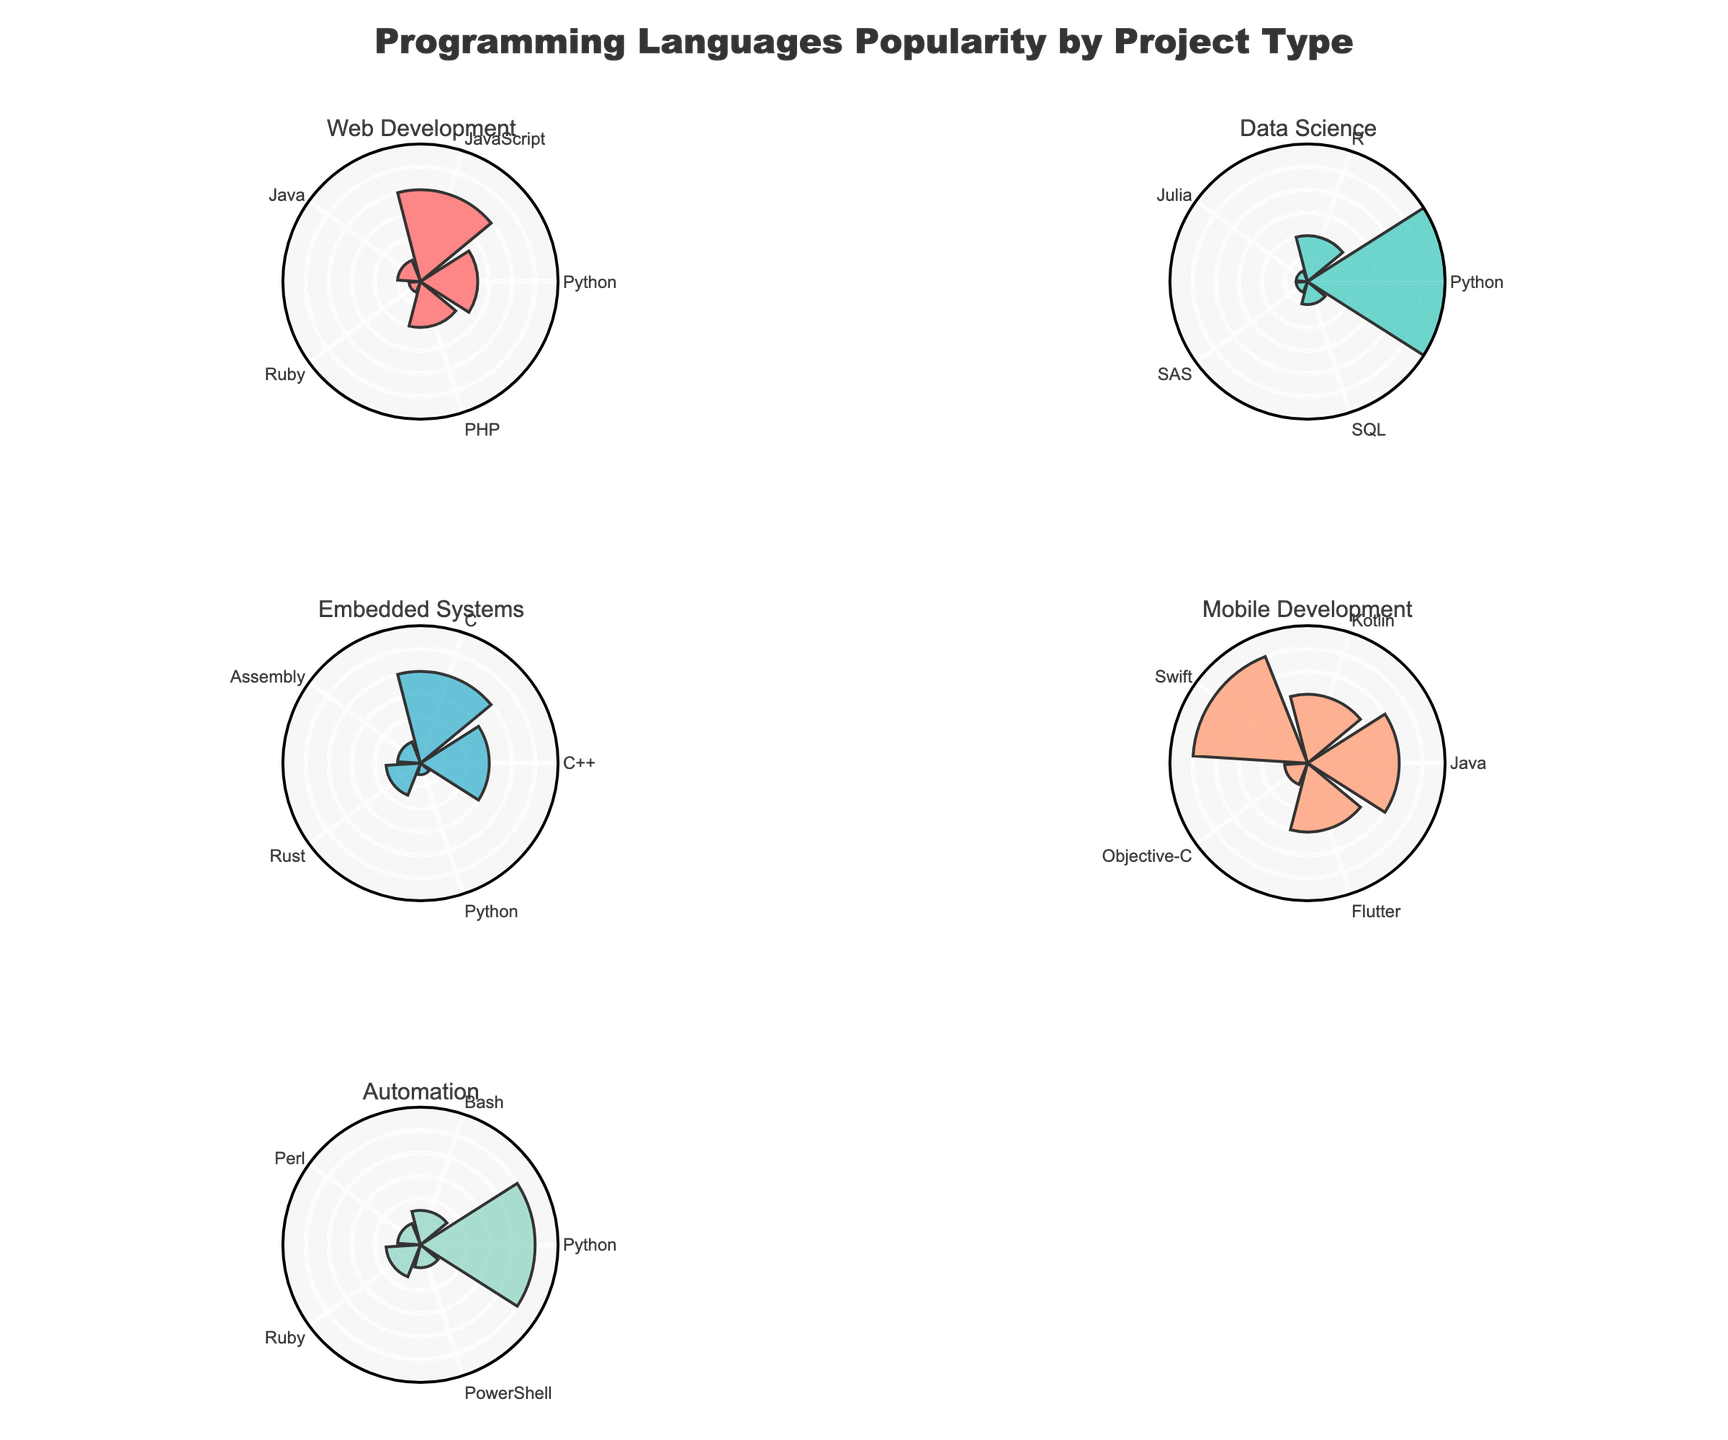What is the title of the figure? The title is displayed at the top of the figure and provides a description of the content. It says "Programming Languages Popularity by Project Type".
Answer: Programming Languages Popularity by Project Type How many subplots are in the figure? Each project type has its own subplot, and there are five unique project types: Web Development, Data Science, Embedded Systems, Mobile Development, and Automation. Thus, there are five subplots.
Answer: Five Which programming language has the highest popularity in Mobile Development? Looking at the Mobile Development subplot, Swift has the highest radial value compared to others.
Answer: Swift How does Python's popularity in Web Development compare to its popularity in Data Science? In the Web Development subplot, Python has a radial value of 25. In the Data Science subplot, Python has a radial value of 60. Therefore, Python is more popular in Data Science than in Web Development.
Answer: More popular in Data Science Which project type has the least popular programming language at the lowest value? In the Data Science subplot, the least popular languages (Julia and SAS) show a radial value of 5, which is the smallest value in all subplots.
Answer: Data Science Compare the popularity of Java in Web Development to its popularity in Mobile Development. In the Web Development subplot, Java has a radial value of 10. In the Mobile Development subplot, Java has a radial value of 40. Therefore, Java is more popular in Mobile Development.
Answer: More popular in Mobile Development What is the average popularity of programming languages in the Embedded Systems project type? The popularity values in Embedded Systems are 30 (C++), 40 (C), 10 (Assembly), 15 (Rust), and 5 (Python). The average is calculated as (30 + 40 + 10 + 15 + 5) / 5 = 20.
Answer: 20 Which project type features the highest single popularity value? The highest radial distance is observed in the Data Science subplot for Python, with a value of 60.
Answer: Data Science What is the combined popularity of all programming languages in the Automation project type? The radial values for Automation are 50 (Python), 15 (Bash), 10 (Perl), 15 (Ruby), and 10 (PowerShell). Their sum is 50 + 15 + 10 + 15 + 10 = 100.
Answer: 100 